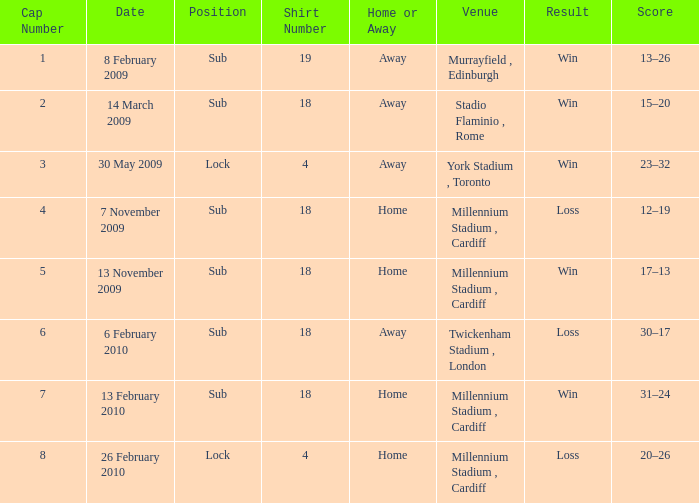Can you indicate if the home or away team has a shirt number exceeding 18? Away. 